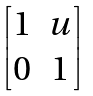<formula> <loc_0><loc_0><loc_500><loc_500>\begin{bmatrix} 1 & u \\ 0 & 1 \\ \end{bmatrix}</formula> 